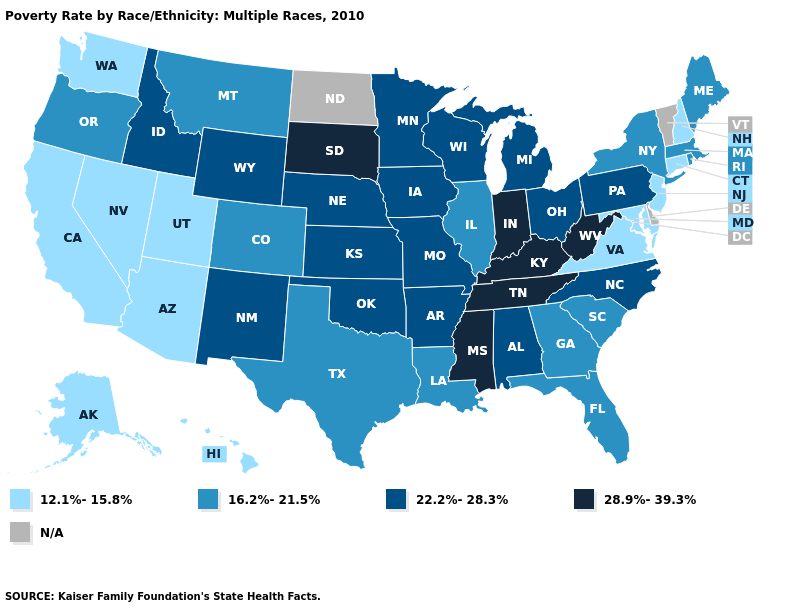Name the states that have a value in the range 28.9%-39.3%?
Answer briefly. Indiana, Kentucky, Mississippi, South Dakota, Tennessee, West Virginia. How many symbols are there in the legend?
Concise answer only. 5. Which states have the lowest value in the Northeast?
Quick response, please. Connecticut, New Hampshire, New Jersey. What is the value of Nebraska?
Answer briefly. 22.2%-28.3%. Does the first symbol in the legend represent the smallest category?
Answer briefly. Yes. Among the states that border North Dakota , which have the lowest value?
Quick response, please. Montana. What is the value of Wyoming?
Concise answer only. 22.2%-28.3%. Does the first symbol in the legend represent the smallest category?
Quick response, please. Yes. Name the states that have a value in the range N/A?
Write a very short answer. Delaware, North Dakota, Vermont. Does Pennsylvania have the highest value in the Northeast?
Quick response, please. Yes. Name the states that have a value in the range N/A?
Give a very brief answer. Delaware, North Dakota, Vermont. What is the value of Utah?
Give a very brief answer. 12.1%-15.8%. What is the lowest value in the South?
Short answer required. 12.1%-15.8%. What is the value of Arizona?
Quick response, please. 12.1%-15.8%. Which states hav the highest value in the MidWest?
Quick response, please. Indiana, South Dakota. 